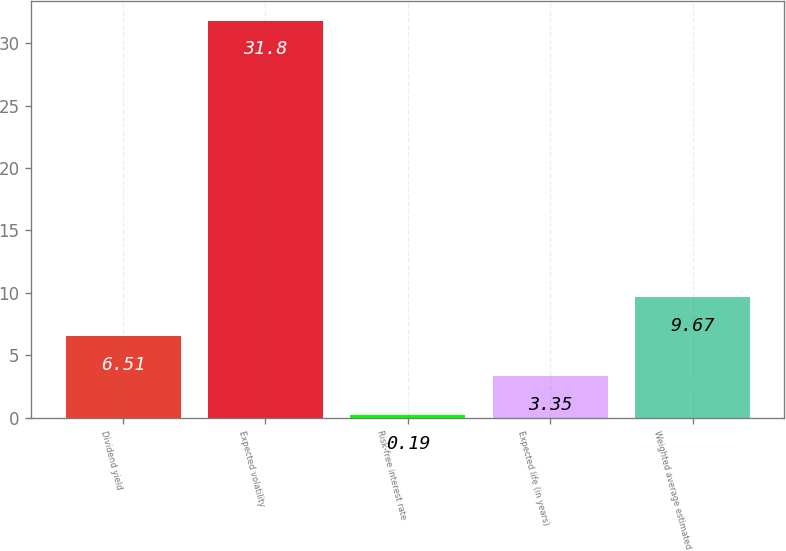<chart> <loc_0><loc_0><loc_500><loc_500><bar_chart><fcel>Dividend yield<fcel>Expected volatility<fcel>Risk-free interest rate<fcel>Expected life (in years)<fcel>Weighted average estimated<nl><fcel>6.51<fcel>31.8<fcel>0.19<fcel>3.35<fcel>9.67<nl></chart> 